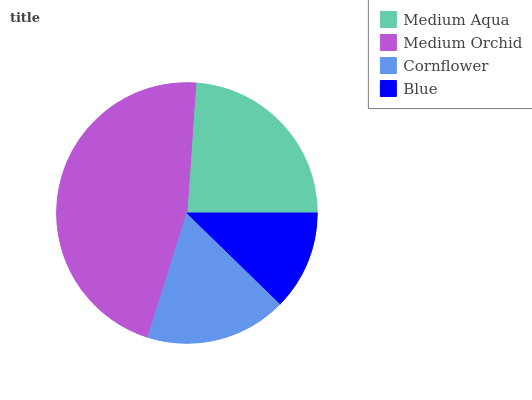Is Blue the minimum?
Answer yes or no. Yes. Is Medium Orchid the maximum?
Answer yes or no. Yes. Is Cornflower the minimum?
Answer yes or no. No. Is Cornflower the maximum?
Answer yes or no. No. Is Medium Orchid greater than Cornflower?
Answer yes or no. Yes. Is Cornflower less than Medium Orchid?
Answer yes or no. Yes. Is Cornflower greater than Medium Orchid?
Answer yes or no. No. Is Medium Orchid less than Cornflower?
Answer yes or no. No. Is Medium Aqua the high median?
Answer yes or no. Yes. Is Cornflower the low median?
Answer yes or no. Yes. Is Blue the high median?
Answer yes or no. No. Is Medium Orchid the low median?
Answer yes or no. No. 